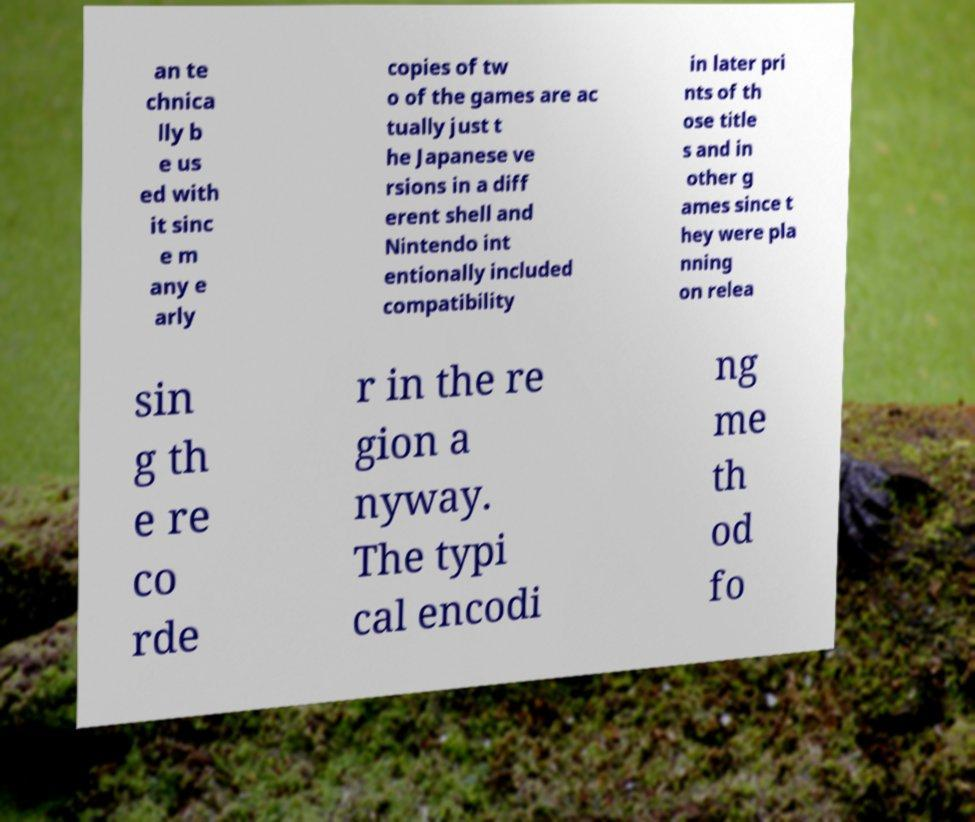There's text embedded in this image that I need extracted. Can you transcribe it verbatim? an te chnica lly b e us ed with it sinc e m any e arly copies of tw o of the games are ac tually just t he Japanese ve rsions in a diff erent shell and Nintendo int entionally included compatibility in later pri nts of th ose title s and in other g ames since t hey were pla nning on relea sin g th e re co rde r in the re gion a nyway. The typi cal encodi ng me th od fo 